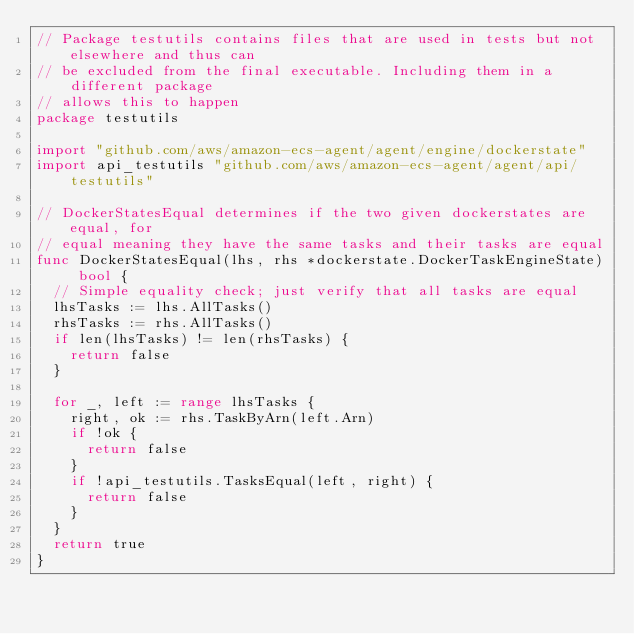<code> <loc_0><loc_0><loc_500><loc_500><_Go_>// Package testutils contains files that are used in tests but not elsewhere and thus can
// be excluded from the final executable. Including them in a different package
// allows this to happen
package testutils

import "github.com/aws/amazon-ecs-agent/agent/engine/dockerstate"
import api_testutils "github.com/aws/amazon-ecs-agent/agent/api/testutils"

// DockerStatesEqual determines if the two given dockerstates are equal, for
// equal meaning they have the same tasks and their tasks are equal
func DockerStatesEqual(lhs, rhs *dockerstate.DockerTaskEngineState) bool {
	// Simple equality check; just verify that all tasks are equal
	lhsTasks := lhs.AllTasks()
	rhsTasks := rhs.AllTasks()
	if len(lhsTasks) != len(rhsTasks) {
		return false
	}

	for _, left := range lhsTasks {
		right, ok := rhs.TaskByArn(left.Arn)
		if !ok {
			return false
		}
		if !api_testutils.TasksEqual(left, right) {
			return false
		}
	}
	return true
}
</code> 